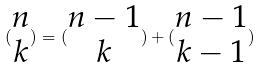Convert formula to latex. <formula><loc_0><loc_0><loc_500><loc_500>( \begin{matrix} n \\ k \end{matrix} ) = ( \begin{matrix} n - 1 \\ k \end{matrix} ) + ( \begin{matrix} n - 1 \\ k - 1 \end{matrix} )</formula> 